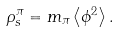<formula> <loc_0><loc_0><loc_500><loc_500>\rho ^ { \pi } _ { s } = m _ { \pi } \left \langle \phi ^ { 2 } \right \rangle .</formula> 